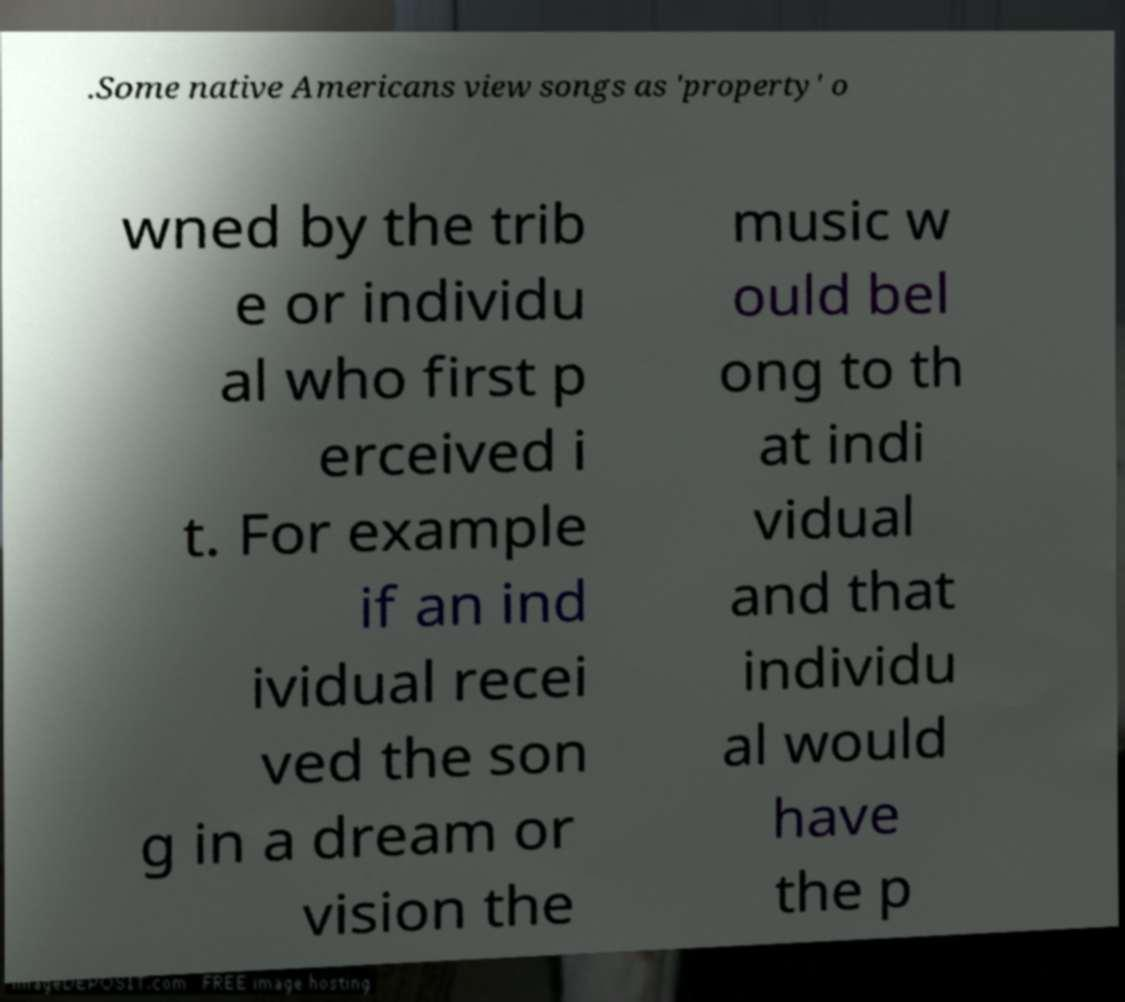Could you extract and type out the text from this image? .Some native Americans view songs as 'property' o wned by the trib e or individu al who first p erceived i t. For example if an ind ividual recei ved the son g in a dream or vision the music w ould bel ong to th at indi vidual and that individu al would have the p 